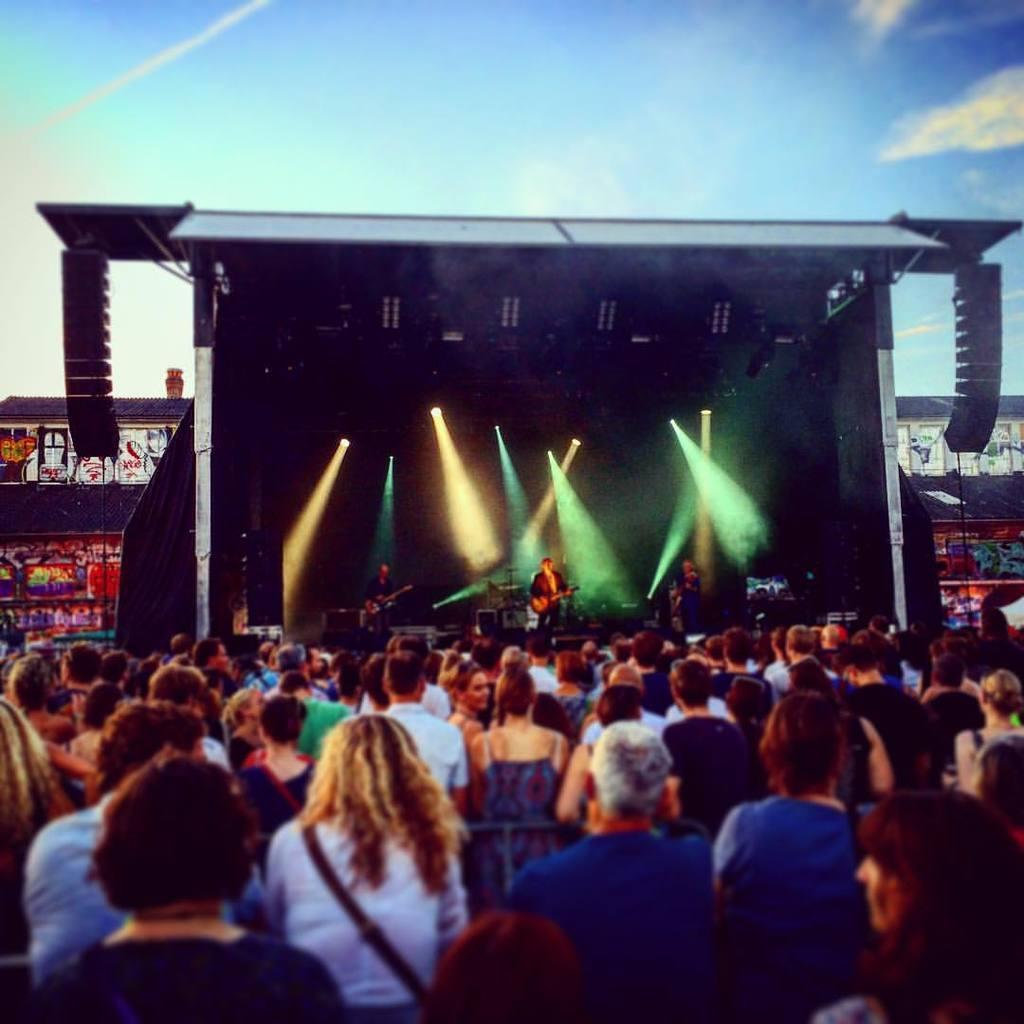How would you summarize this image in a sentence or two? In this picture, we see many people are standing. In the middle of the picture, we see three men are standing on the stage and they are playing the musical instruments. In front of them, we see the microphones. Behind them, we see a black color sheet and we see the lights. In the background, we see a building with black color roof and we some posts are posted on the wall. In the background, we see some objects. At the top, we see the sky. 